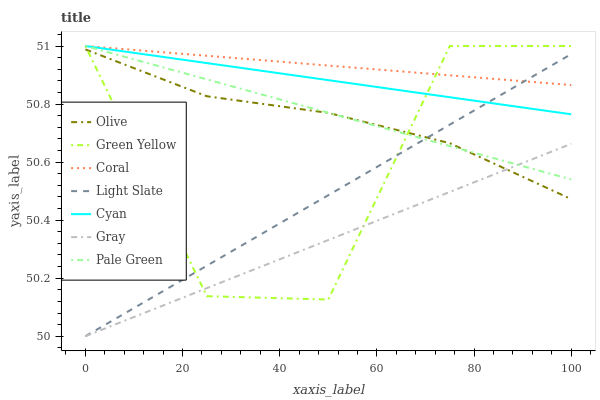Does Gray have the minimum area under the curve?
Answer yes or no. Yes. Does Coral have the maximum area under the curve?
Answer yes or no. Yes. Does Light Slate have the minimum area under the curve?
Answer yes or no. No. Does Light Slate have the maximum area under the curve?
Answer yes or no. No. Is Gray the smoothest?
Answer yes or no. Yes. Is Green Yellow the roughest?
Answer yes or no. Yes. Is Coral the smoothest?
Answer yes or no. No. Is Coral the roughest?
Answer yes or no. No. Does Gray have the lowest value?
Answer yes or no. Yes. Does Coral have the lowest value?
Answer yes or no. No. Does Green Yellow have the highest value?
Answer yes or no. Yes. Does Light Slate have the highest value?
Answer yes or no. No. Is Olive less than Coral?
Answer yes or no. Yes. Is Coral greater than Olive?
Answer yes or no. Yes. Does Gray intersect Light Slate?
Answer yes or no. Yes. Is Gray less than Light Slate?
Answer yes or no. No. Is Gray greater than Light Slate?
Answer yes or no. No. Does Olive intersect Coral?
Answer yes or no. No. 